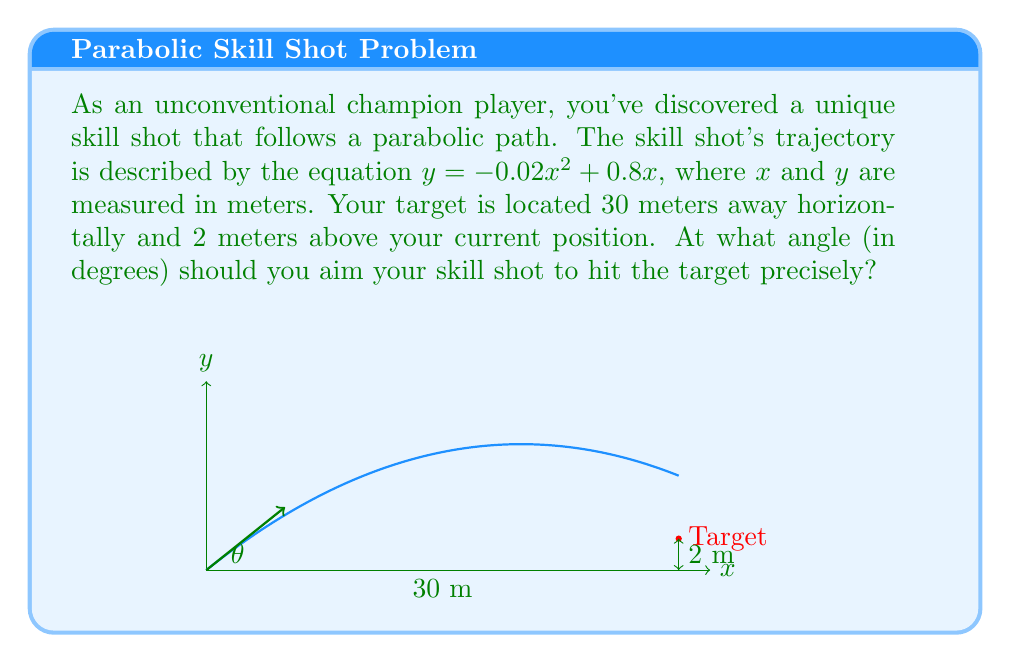Provide a solution to this math problem. To solve this problem, we need to follow these steps:

1) The parabolic equation of the skill shot is given by $y = -0.02x^2 + 0.8x$.

2) We know the target coordinates: $(30, 2)$. Let's verify if this point satisfies our equation:

   $y = -0.02(30)^2 + 0.8(30)$
   $y = -0.02(900) + 24$
   $y = -18 + 24 = 6$

   This doesn't equal 2, so we need to adjust our initial angle.

3) To find the angle, we need to calculate the derivative of our function at $x = 30$:

   $\frac{dy}{dx} = -0.04x + 0.8$
   At $x = 30$: $\frac{dy}{dx} = -0.04(30) + 0.8 = -0.4$

4) The tangent of our angle is the negative reciprocal of this slope:

   $\tan(\theta) = -\frac{1}{-0.4} = 2.5$

5) To get the angle in degrees, we use the arctangent function:

   $\theta = \arctan(2.5)$

6) Convert radians to degrees:

   $\theta = \arctan(2.5) \cdot \frac{180}{\pi} \approx 68.20^\circ$

Therefore, you should aim your skill shot at approximately 68.20 degrees above the horizontal to hit the target precisely.
Answer: $68.20^\circ$ 